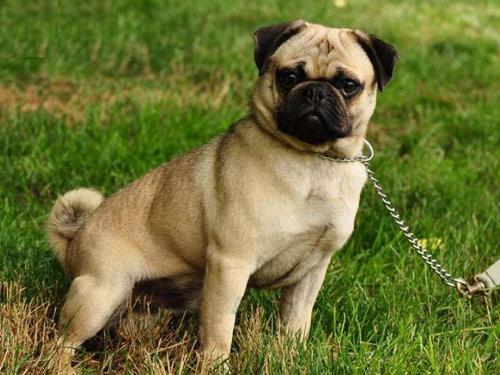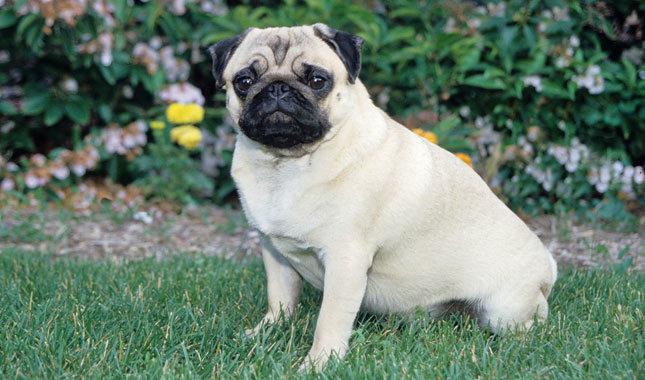The first image is the image on the left, the second image is the image on the right. Assess this claim about the two images: "The lighter colored dog is sitting in the grass.". Correct or not? Answer yes or no. Yes. 